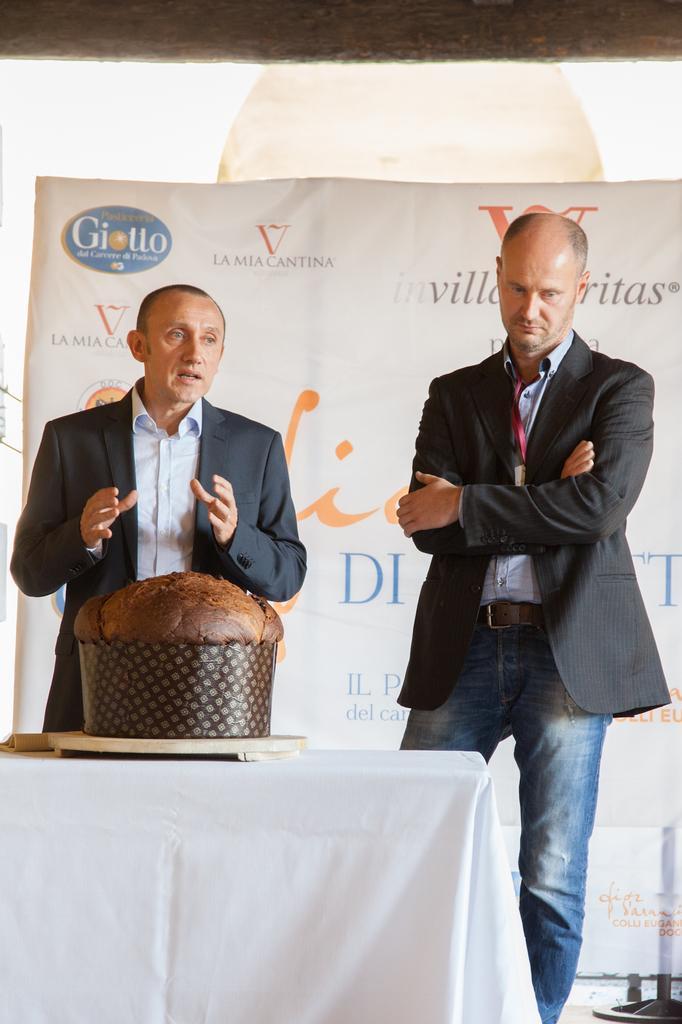Describe this image in one or two sentences. This picture shows two men standing and a man speaking and we see a cake on the table and we see a hoarding on their back 